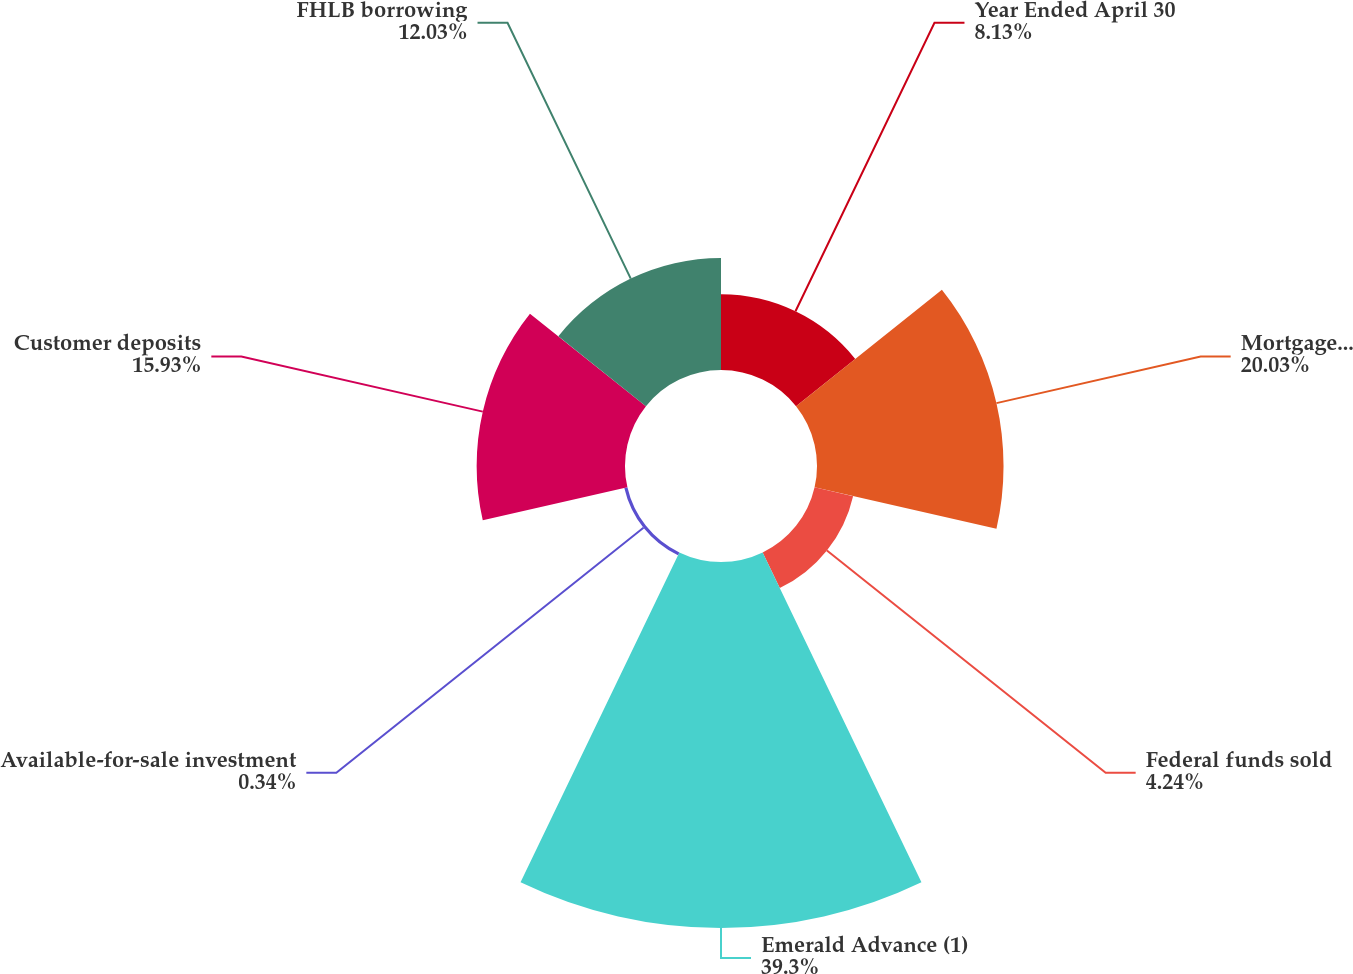<chart> <loc_0><loc_0><loc_500><loc_500><pie_chart><fcel>Year Ended April 30<fcel>Mortgage loans net<fcel>Federal funds sold<fcel>Emerald Advance (1)<fcel>Available-for-sale investment<fcel>Customer deposits<fcel>FHLB borrowing<nl><fcel>8.13%<fcel>20.03%<fcel>4.24%<fcel>39.3%<fcel>0.34%<fcel>15.93%<fcel>12.03%<nl></chart> 